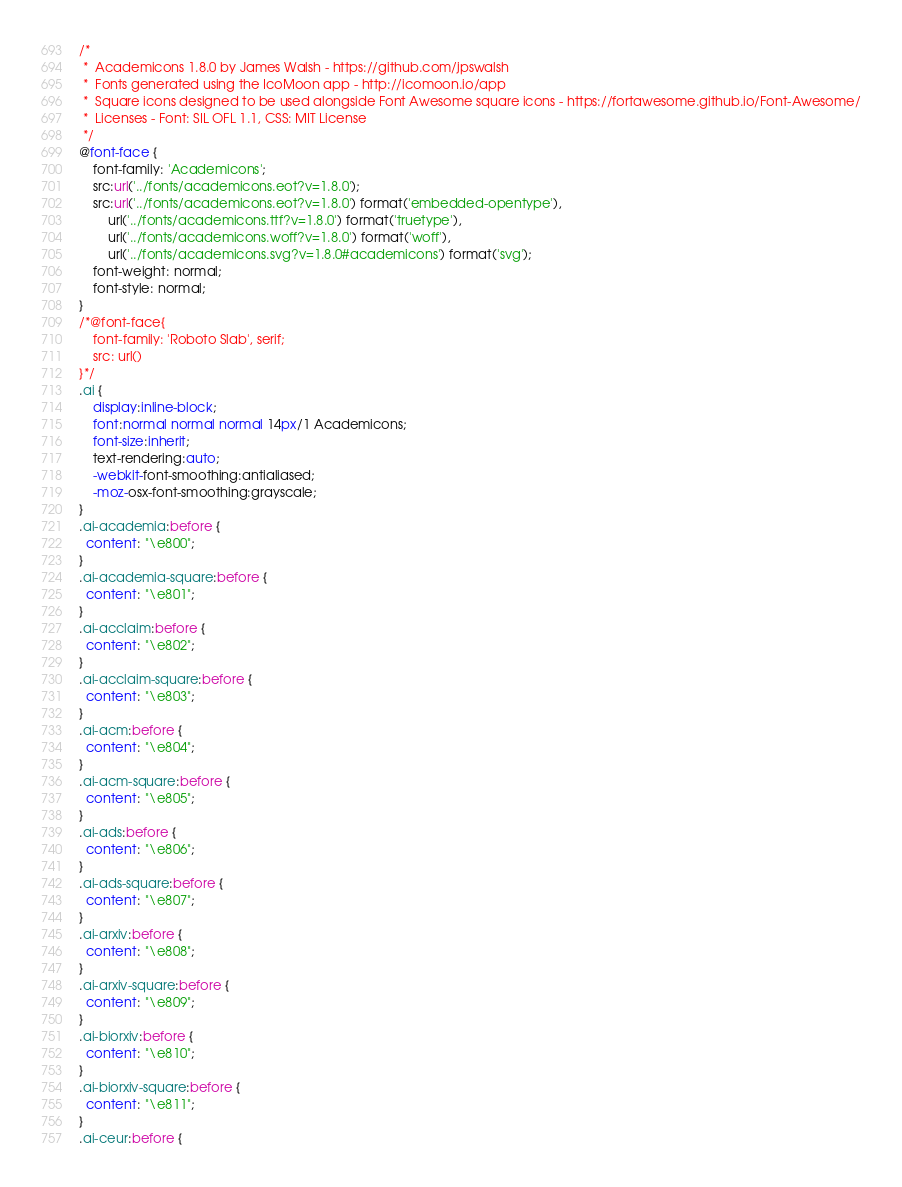<code> <loc_0><loc_0><loc_500><loc_500><_CSS_>/*
 *  Academicons 1.8.0 by James Walsh - https://github.com/jpswalsh
 *  Fonts generated using the IcoMoon app - http://icomoon.io/app
 *  Square icons designed to be used alongside Font Awesome square icons - https://fortawesome.github.io/Font-Awesome/
 *  Licenses - Font: SIL OFL 1.1, CSS: MIT License
 */
@font-face {
    font-family: 'Academicons';
    src:url('../fonts/academicons.eot?v=1.8.0');
    src:url('../fonts/academicons.eot?v=1.8.0') format('embedded-opentype'),
        url('../fonts/academicons.ttf?v=1.8.0') format('truetype'),
        url('../fonts/academicons.woff?v=1.8.0') format('woff'),
        url('../fonts/academicons.svg?v=1.8.0#academicons') format('svg');
    font-weight: normal;
    font-style: normal;
}
/*@font-face{
	font-family: 'Roboto Slab', serif;
	src: url()
}*/
.ai {
	display:inline-block;
	font:normal normal normal 14px/1 Academicons;
	font-size:inherit;
	text-rendering:auto;
	-webkit-font-smoothing:antialiased;
	-moz-osx-font-smoothing:grayscale;
}
.ai-academia:before {
  content: "\e800";
}
.ai-academia-square:before {
  content: "\e801";
}
.ai-acclaim:before {
  content: "\e802";
}
.ai-acclaim-square:before {
  content: "\e803";
}
.ai-acm:before {
  content: "\e804";
}
.ai-acm-square:before {
  content: "\e805";
}
.ai-ads:before {
  content: "\e806";
}
.ai-ads-square:before {
  content: "\e807";
}
.ai-arxiv:before {
  content: "\e808";
}
.ai-arxiv-square:before {
  content: "\e809";
}
.ai-biorxiv:before {
  content: "\e810";
}
.ai-biorxiv-square:before {
  content: "\e811";
}
.ai-ceur:before {</code> 